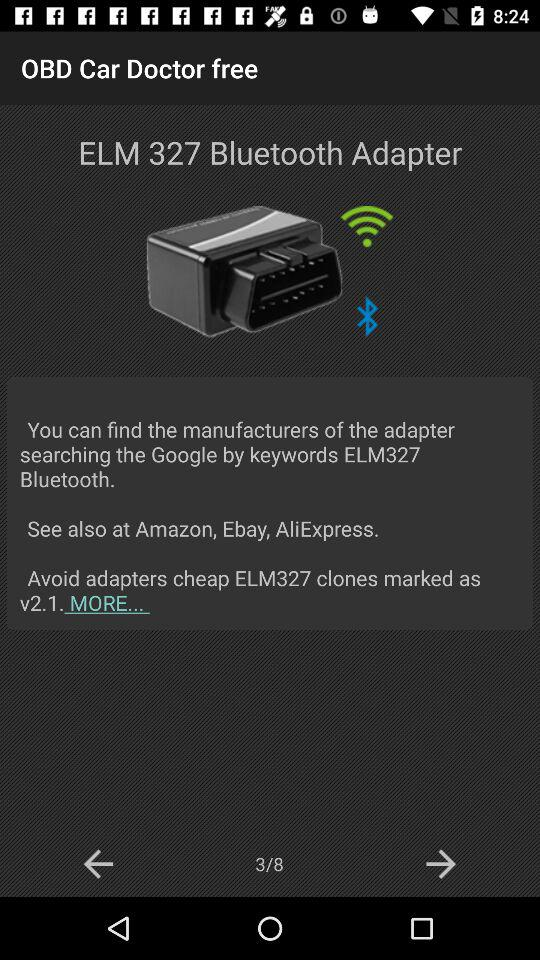Where can I find the manufacturers of the ELM327 Bluetooth Adapter? You can find the manufacturers of the ELM327 Bluetooth Adapter at Google, Amazon, Ebay and AliExpress. 